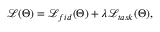<formula> <loc_0><loc_0><loc_500><loc_500>\begin{array} { r } { \mathcal { L } ( \Theta ) = \mathcal { L } _ { f i d } ( \Theta ) + \lambda \mathcal { L } _ { t a s k } ( \Theta ) , } \end{array}</formula> 